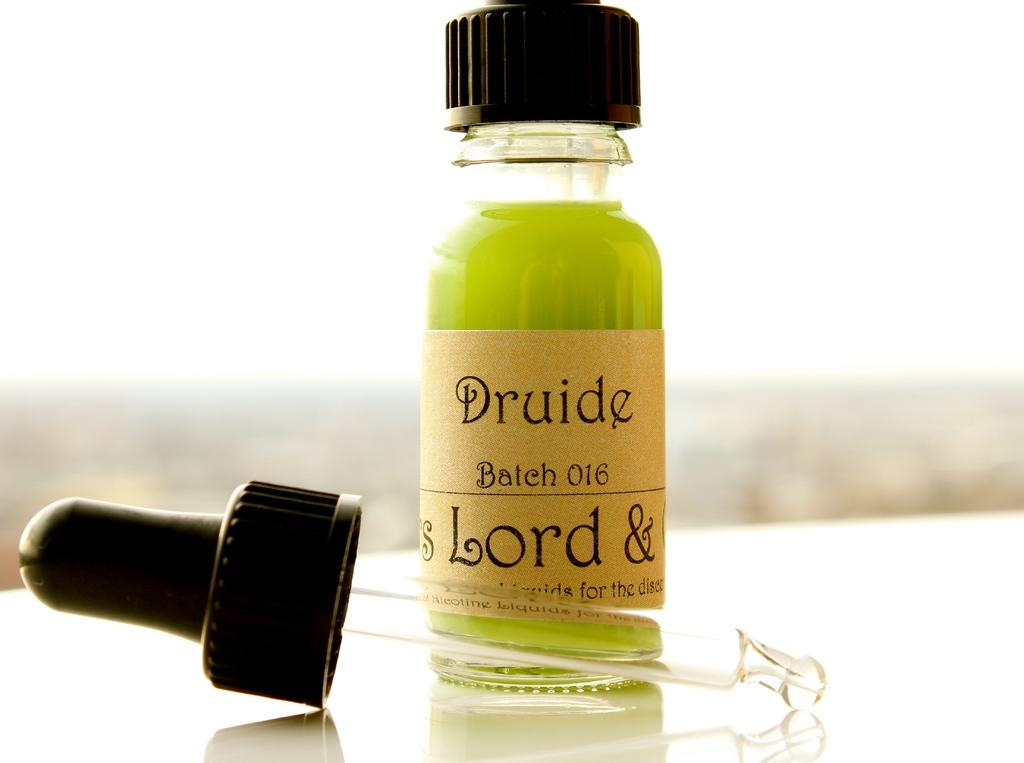<image>
Offer a succinct explanation of the picture presented. A dropper lies on the table in front of a bottle containing a green liquid and a label showing us it is homeopathic medicine called Druide. 